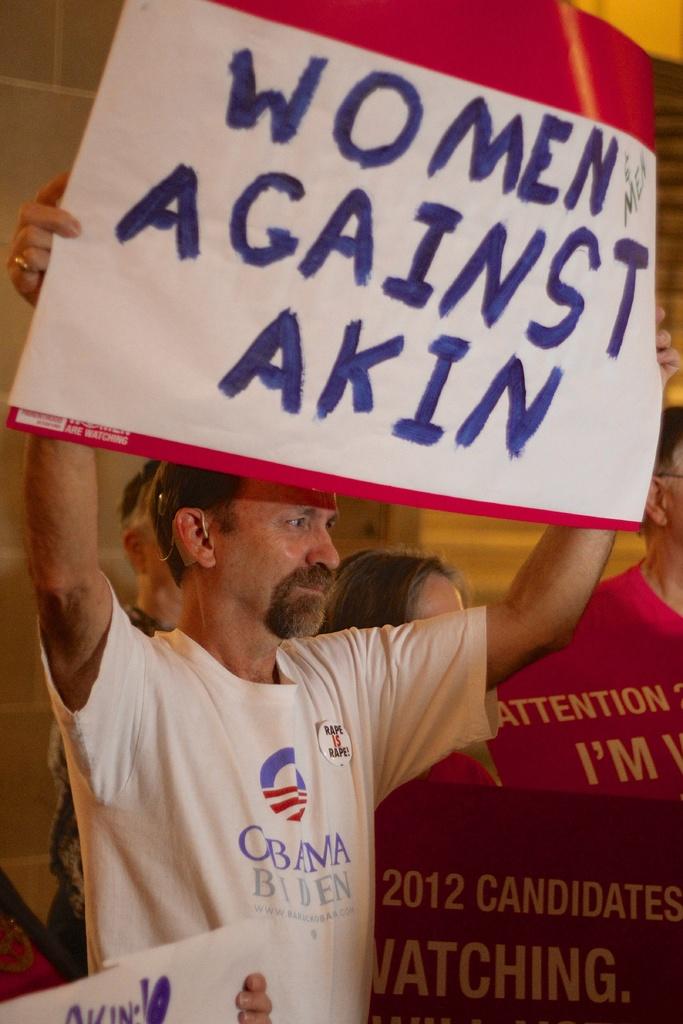What are women against?
Provide a short and direct response. Akin. What year is mentioned here?
Your response must be concise. 2012. 